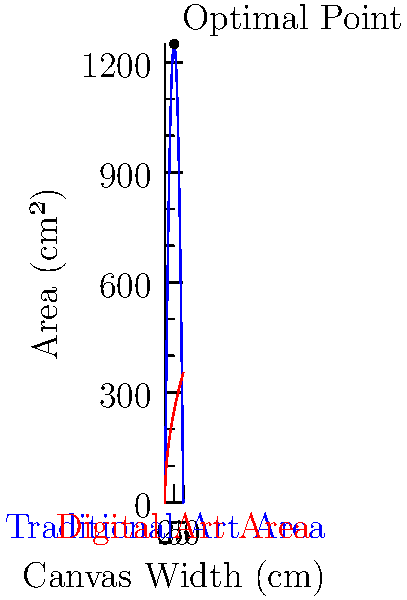For a mixed-media artwork, the area dedicated to traditional art is modeled by the function $A_t(x) = 100x - 2x^2$, where $x$ is the canvas width in centimeters. The area for digital art is given by $A_d(x) = 50\sqrt{x}$. What canvas width maximizes the total artwork area, and what is this maximum area? To solve this optimization problem, we follow these steps:

1) The total area function is $A(x) = A_t(x) + A_d(x) = 100x - 2x^2 + 50\sqrt{x}$

2) To find the maximum, we differentiate $A(x)$ and set it to zero:
   $$A'(x) = 100 - 4x + \frac{25}{\sqrt{x}} = 0$$

3) Multiply both sides by $\sqrt{x}$:
   $$100\sqrt{x} - 4x\sqrt{x} + 25 = 0$$

4) Substitute $u = \sqrt{x}$, so $x = u^2$:
   $$100u - 4u^3 + 25 = 0$$

5) Rearrange:
   $$4u^3 - 100u - 25 = 0$$

6) This cubic equation can be solved numerically. The positive real solution is approximately $u \approx 5$.

7) Since $u = \sqrt{x}$, we have $x = u^2 = 5^2 = 25$ cm.

8) The maximum area is:
   $$A(25) = 100(25) - 2(25)^2 + 50\sqrt{25} = 2500 - 1250 + 250 = 1500\text{ cm}^2$$

Therefore, the optimal canvas width is 25 cm, and the maximum total area is 1500 cm².
Answer: 25 cm width; 1500 cm² area 